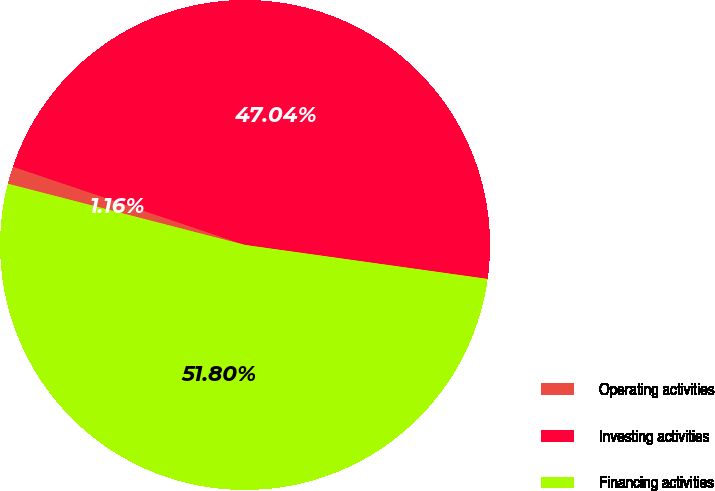Convert chart. <chart><loc_0><loc_0><loc_500><loc_500><pie_chart><fcel>Operating activities<fcel>Investing activities<fcel>Financing activities<nl><fcel>1.16%<fcel>47.04%<fcel>51.81%<nl></chart> 